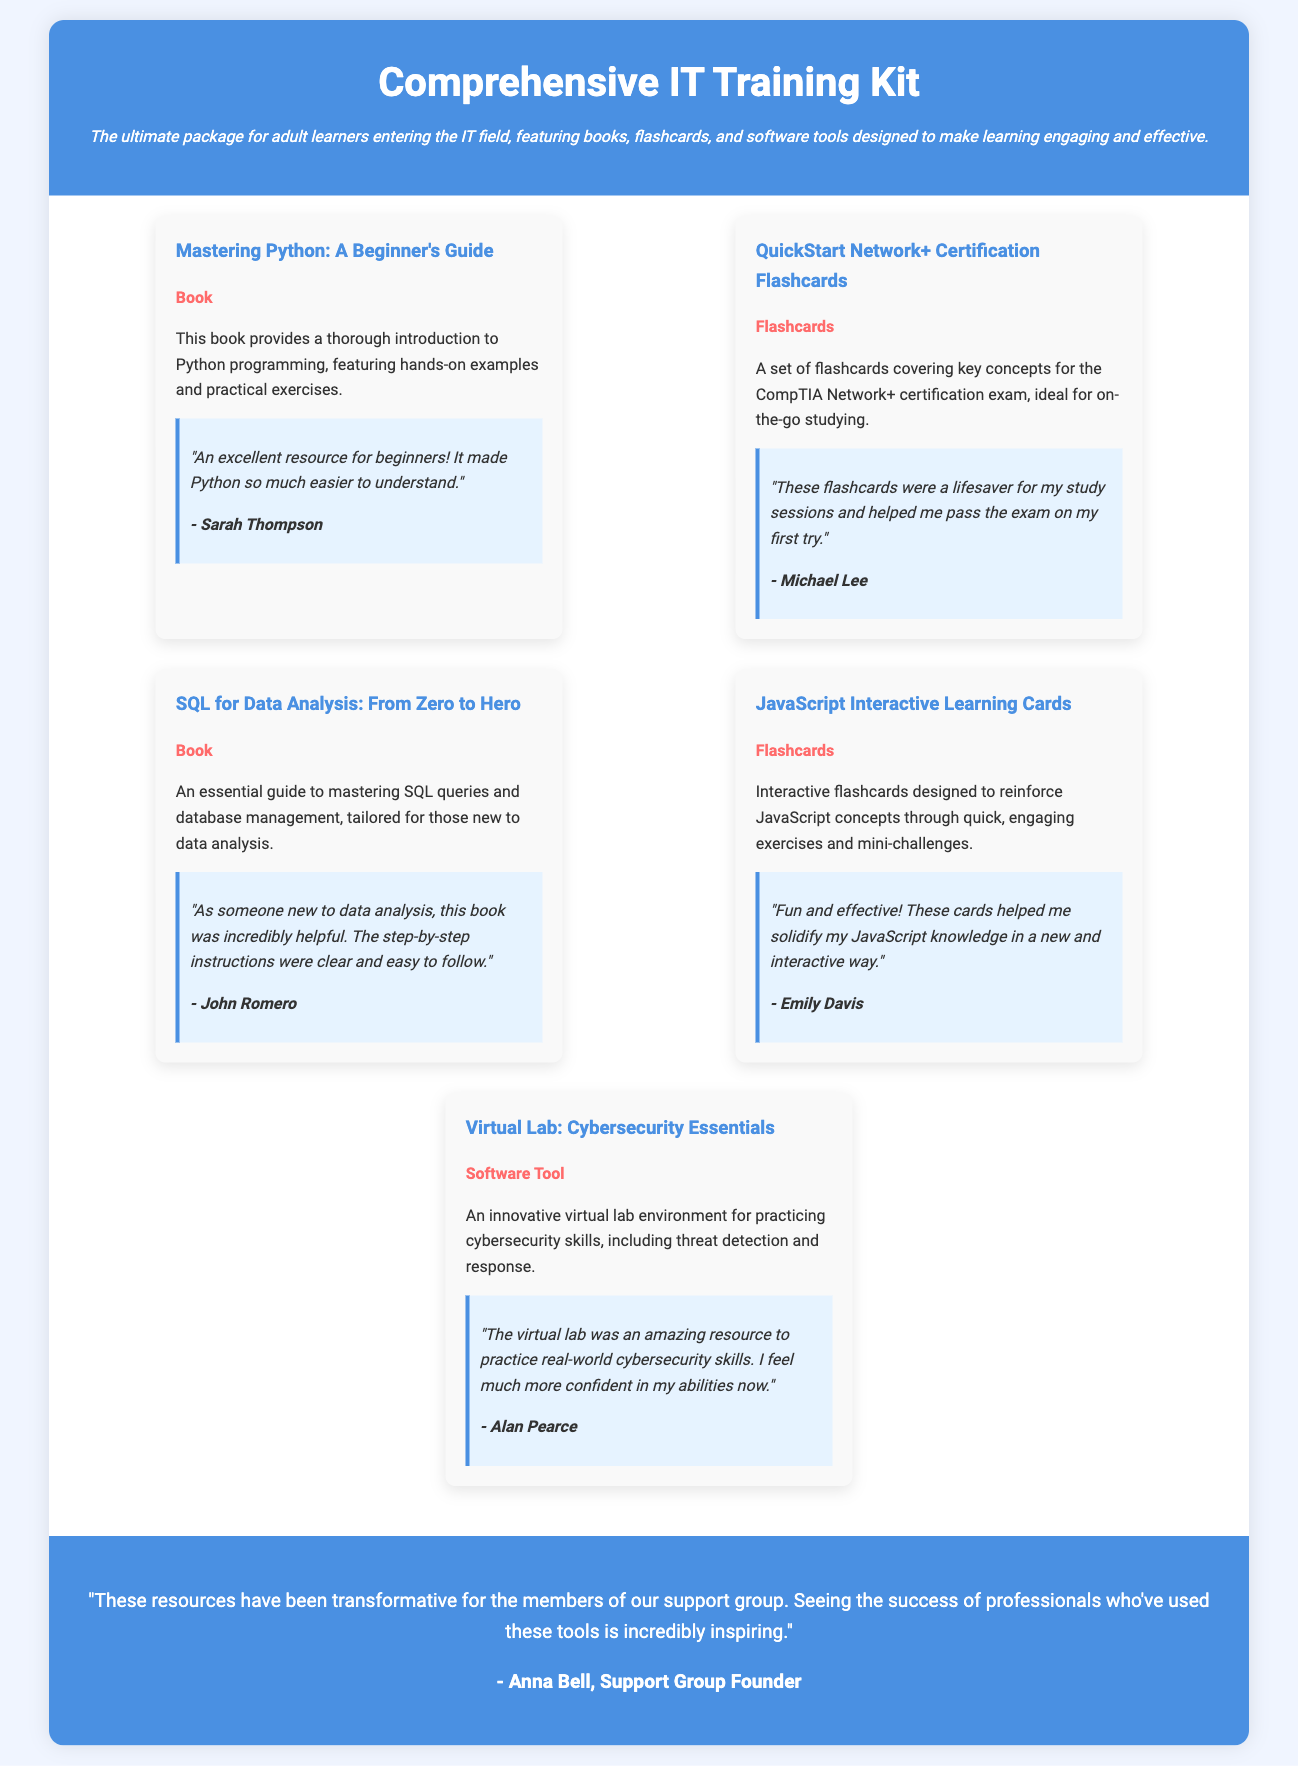What is the title of the first item showcased? The title of the first item showcased in the document is found in the item description section, stating "Mastering Python: A Beginner's Guide."
Answer: Mastering Python: A Beginner's Guide What is the main theme of the Comprehensive IT Training Kit? The main theme, as described in the header, is aimed at providing resources for adult learners entering the IT field.
Answer: Adult learners entering the IT field What testimonial is provided for the Virtual Lab: Cybersecurity Essentials? The testimonial is a user experience shared in the document, specifically highlighting the effectiveness of the lab for practicing skills.
Answer: "The virtual lab was an amazing resource to practice real-world cybersecurity skills. I feel much more confident in my abilities now." How does Anna Bell describe the impact of the resources on the members of the support group? The explanation is based on the overall testimonial attributed to Anna Bell in the document, summarizing the collective effect on the group.
Answer: Transformative What type of educational materials are included in the training kit? The document lists different types of educational materials, including books, flashcards, and software tools.
Answer: Books, flashcards, software tools What color is the overall testimonial background? The document specifies that the color of the overall testimonial background is consistent throughout the styled section.
Answer: Blue 